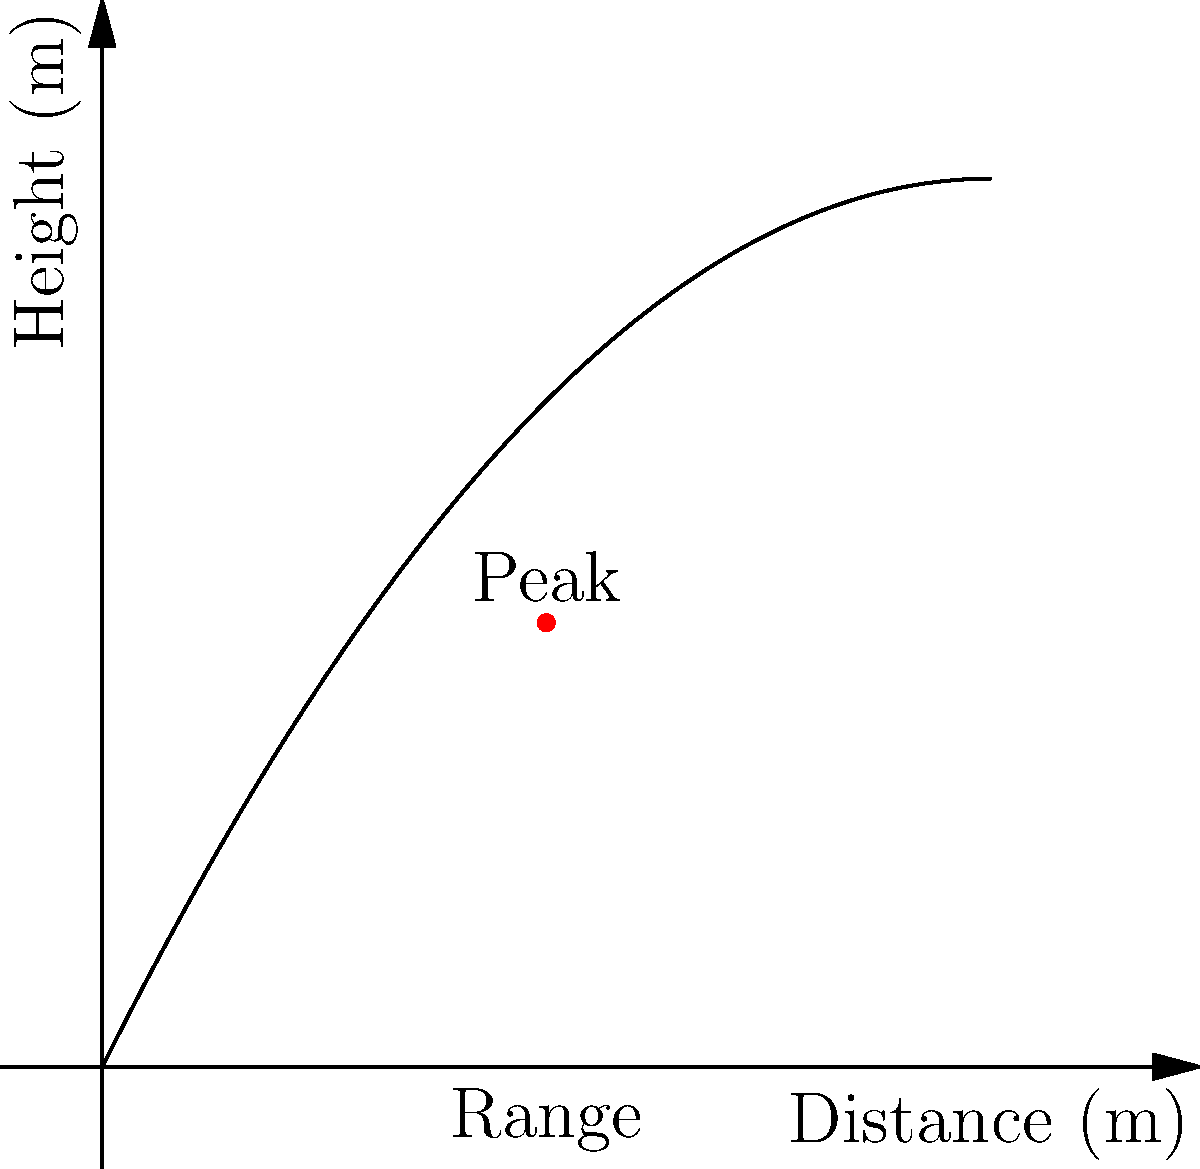A new fountain at Sleeping Bear Dunes National Lakeshore shoots water in a parabolic arc. The trajectory of the water stream can be modeled by the equation $h(x) = -0.1x^2 + 2x$, where $h$ is the height in meters and $x$ is the horizontal distance in meters. What is the maximum height reached by the water, and at what horizontal distance does this occur? To find the maximum height and its corresponding horizontal distance, we need to follow these steps:

1) The maximum height occurs at the vertex of the parabola. For a quadratic function in the form $f(x) = ax^2 + bx + c$, the x-coordinate of the vertex is given by $x = -\frac{b}{2a}$.

2) In our equation $h(x) = -0.1x^2 + 2x$, we have:
   $a = -0.1$
   $b = 2$
   $c = 0$

3) Plugging into the vertex formula:
   $x = -\frac{2}{2(-0.1)} = -\frac{2}{-0.2} = 10$

4) The x-coordinate of the vertex is 5 meters.

5) To find the maximum height, we substitute this x-value back into the original equation:
   $h(5) = -0.1(5)^2 + 2(5)$
   $= -0.1(25) + 10$
   $= -2.5 + 10$
   $= 7.5$

Therefore, the maximum height is 5 meters, occurring at a horizontal distance of 5 meters.
Answer: Maximum height: 5 m; Horizontal distance: 5 m 